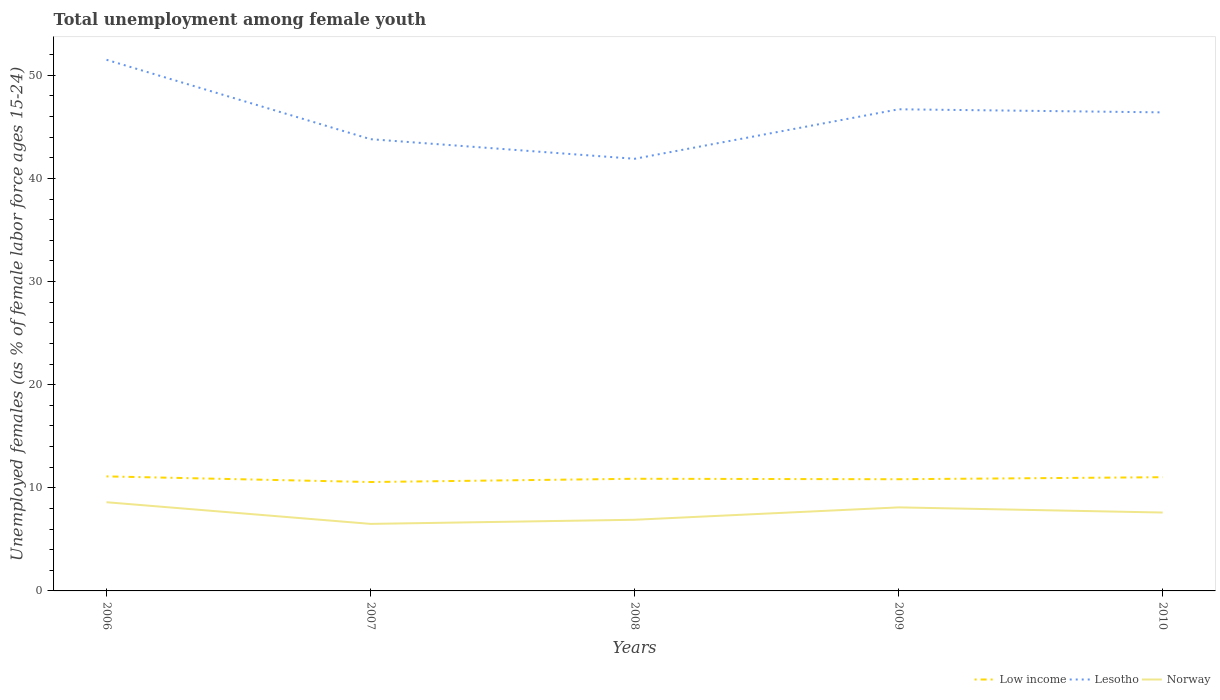How many different coloured lines are there?
Your answer should be very brief. 3. Does the line corresponding to Norway intersect with the line corresponding to Low income?
Your response must be concise. No. Is the number of lines equal to the number of legend labels?
Ensure brevity in your answer.  Yes. Across all years, what is the maximum percentage of unemployed females in in Low income?
Keep it short and to the point. 10.56. In which year was the percentage of unemployed females in in Norway maximum?
Provide a succinct answer. 2007. What is the total percentage of unemployed females in in Low income in the graph?
Keep it short and to the point. -0.47. What is the difference between the highest and the second highest percentage of unemployed females in in Lesotho?
Your answer should be compact. 9.6. Is the percentage of unemployed females in in Norway strictly greater than the percentage of unemployed females in in Lesotho over the years?
Provide a succinct answer. Yes. How many years are there in the graph?
Make the answer very short. 5. Are the values on the major ticks of Y-axis written in scientific E-notation?
Your answer should be very brief. No. How many legend labels are there?
Make the answer very short. 3. What is the title of the graph?
Your answer should be very brief. Total unemployment among female youth. What is the label or title of the X-axis?
Your answer should be compact. Years. What is the label or title of the Y-axis?
Provide a succinct answer. Unemployed females (as % of female labor force ages 15-24). What is the Unemployed females (as % of female labor force ages 15-24) of Low income in 2006?
Offer a terse response. 11.1. What is the Unemployed females (as % of female labor force ages 15-24) in Lesotho in 2006?
Your response must be concise. 51.5. What is the Unemployed females (as % of female labor force ages 15-24) in Norway in 2006?
Provide a succinct answer. 8.6. What is the Unemployed females (as % of female labor force ages 15-24) in Low income in 2007?
Keep it short and to the point. 10.56. What is the Unemployed females (as % of female labor force ages 15-24) in Lesotho in 2007?
Your answer should be very brief. 43.8. What is the Unemployed females (as % of female labor force ages 15-24) in Norway in 2007?
Ensure brevity in your answer.  6.5. What is the Unemployed females (as % of female labor force ages 15-24) of Low income in 2008?
Keep it short and to the point. 10.87. What is the Unemployed females (as % of female labor force ages 15-24) in Lesotho in 2008?
Offer a terse response. 41.9. What is the Unemployed females (as % of female labor force ages 15-24) of Norway in 2008?
Provide a short and direct response. 6.9. What is the Unemployed females (as % of female labor force ages 15-24) in Low income in 2009?
Offer a very short reply. 10.83. What is the Unemployed females (as % of female labor force ages 15-24) in Lesotho in 2009?
Your response must be concise. 46.7. What is the Unemployed females (as % of female labor force ages 15-24) in Norway in 2009?
Your answer should be very brief. 8.1. What is the Unemployed females (as % of female labor force ages 15-24) in Low income in 2010?
Your answer should be very brief. 11.03. What is the Unemployed females (as % of female labor force ages 15-24) in Lesotho in 2010?
Provide a succinct answer. 46.4. What is the Unemployed females (as % of female labor force ages 15-24) of Norway in 2010?
Give a very brief answer. 7.6. Across all years, what is the maximum Unemployed females (as % of female labor force ages 15-24) of Low income?
Make the answer very short. 11.1. Across all years, what is the maximum Unemployed females (as % of female labor force ages 15-24) in Lesotho?
Your response must be concise. 51.5. Across all years, what is the maximum Unemployed females (as % of female labor force ages 15-24) of Norway?
Ensure brevity in your answer.  8.6. Across all years, what is the minimum Unemployed females (as % of female labor force ages 15-24) of Low income?
Your answer should be compact. 10.56. Across all years, what is the minimum Unemployed females (as % of female labor force ages 15-24) of Lesotho?
Provide a succinct answer. 41.9. Across all years, what is the minimum Unemployed females (as % of female labor force ages 15-24) in Norway?
Ensure brevity in your answer.  6.5. What is the total Unemployed females (as % of female labor force ages 15-24) in Low income in the graph?
Offer a terse response. 54.39. What is the total Unemployed females (as % of female labor force ages 15-24) of Lesotho in the graph?
Make the answer very short. 230.3. What is the total Unemployed females (as % of female labor force ages 15-24) of Norway in the graph?
Ensure brevity in your answer.  37.7. What is the difference between the Unemployed females (as % of female labor force ages 15-24) in Low income in 2006 and that in 2007?
Keep it short and to the point. 0.55. What is the difference between the Unemployed females (as % of female labor force ages 15-24) in Low income in 2006 and that in 2008?
Your response must be concise. 0.23. What is the difference between the Unemployed females (as % of female labor force ages 15-24) of Norway in 2006 and that in 2008?
Your answer should be very brief. 1.7. What is the difference between the Unemployed females (as % of female labor force ages 15-24) of Low income in 2006 and that in 2009?
Your answer should be compact. 0.28. What is the difference between the Unemployed females (as % of female labor force ages 15-24) of Norway in 2006 and that in 2009?
Your answer should be compact. 0.5. What is the difference between the Unemployed females (as % of female labor force ages 15-24) in Low income in 2006 and that in 2010?
Provide a succinct answer. 0.08. What is the difference between the Unemployed females (as % of female labor force ages 15-24) of Norway in 2006 and that in 2010?
Your answer should be very brief. 1. What is the difference between the Unemployed females (as % of female labor force ages 15-24) in Low income in 2007 and that in 2008?
Keep it short and to the point. -0.32. What is the difference between the Unemployed females (as % of female labor force ages 15-24) of Lesotho in 2007 and that in 2008?
Give a very brief answer. 1.9. What is the difference between the Unemployed females (as % of female labor force ages 15-24) in Low income in 2007 and that in 2009?
Your answer should be very brief. -0.27. What is the difference between the Unemployed females (as % of female labor force ages 15-24) in Lesotho in 2007 and that in 2009?
Ensure brevity in your answer.  -2.9. What is the difference between the Unemployed females (as % of female labor force ages 15-24) in Low income in 2007 and that in 2010?
Give a very brief answer. -0.47. What is the difference between the Unemployed females (as % of female labor force ages 15-24) of Lesotho in 2007 and that in 2010?
Provide a succinct answer. -2.6. What is the difference between the Unemployed females (as % of female labor force ages 15-24) of Norway in 2007 and that in 2010?
Your response must be concise. -1.1. What is the difference between the Unemployed females (as % of female labor force ages 15-24) of Low income in 2008 and that in 2009?
Provide a short and direct response. 0.04. What is the difference between the Unemployed females (as % of female labor force ages 15-24) of Lesotho in 2008 and that in 2009?
Give a very brief answer. -4.8. What is the difference between the Unemployed females (as % of female labor force ages 15-24) of Low income in 2008 and that in 2010?
Ensure brevity in your answer.  -0.15. What is the difference between the Unemployed females (as % of female labor force ages 15-24) in Lesotho in 2008 and that in 2010?
Provide a short and direct response. -4.5. What is the difference between the Unemployed females (as % of female labor force ages 15-24) in Norway in 2008 and that in 2010?
Give a very brief answer. -0.7. What is the difference between the Unemployed females (as % of female labor force ages 15-24) in Low income in 2009 and that in 2010?
Your response must be concise. -0.2. What is the difference between the Unemployed females (as % of female labor force ages 15-24) in Norway in 2009 and that in 2010?
Provide a short and direct response. 0.5. What is the difference between the Unemployed females (as % of female labor force ages 15-24) in Low income in 2006 and the Unemployed females (as % of female labor force ages 15-24) in Lesotho in 2007?
Ensure brevity in your answer.  -32.7. What is the difference between the Unemployed females (as % of female labor force ages 15-24) in Low income in 2006 and the Unemployed females (as % of female labor force ages 15-24) in Norway in 2007?
Provide a succinct answer. 4.6. What is the difference between the Unemployed females (as % of female labor force ages 15-24) in Low income in 2006 and the Unemployed females (as % of female labor force ages 15-24) in Lesotho in 2008?
Your answer should be compact. -30.8. What is the difference between the Unemployed females (as % of female labor force ages 15-24) in Low income in 2006 and the Unemployed females (as % of female labor force ages 15-24) in Norway in 2008?
Your answer should be very brief. 4.2. What is the difference between the Unemployed females (as % of female labor force ages 15-24) of Lesotho in 2006 and the Unemployed females (as % of female labor force ages 15-24) of Norway in 2008?
Keep it short and to the point. 44.6. What is the difference between the Unemployed females (as % of female labor force ages 15-24) in Low income in 2006 and the Unemployed females (as % of female labor force ages 15-24) in Lesotho in 2009?
Provide a short and direct response. -35.6. What is the difference between the Unemployed females (as % of female labor force ages 15-24) in Low income in 2006 and the Unemployed females (as % of female labor force ages 15-24) in Norway in 2009?
Make the answer very short. 3. What is the difference between the Unemployed females (as % of female labor force ages 15-24) of Lesotho in 2006 and the Unemployed females (as % of female labor force ages 15-24) of Norway in 2009?
Your answer should be compact. 43.4. What is the difference between the Unemployed females (as % of female labor force ages 15-24) of Low income in 2006 and the Unemployed females (as % of female labor force ages 15-24) of Lesotho in 2010?
Offer a terse response. -35.3. What is the difference between the Unemployed females (as % of female labor force ages 15-24) of Low income in 2006 and the Unemployed females (as % of female labor force ages 15-24) of Norway in 2010?
Ensure brevity in your answer.  3.5. What is the difference between the Unemployed females (as % of female labor force ages 15-24) in Lesotho in 2006 and the Unemployed females (as % of female labor force ages 15-24) in Norway in 2010?
Give a very brief answer. 43.9. What is the difference between the Unemployed females (as % of female labor force ages 15-24) in Low income in 2007 and the Unemployed females (as % of female labor force ages 15-24) in Lesotho in 2008?
Offer a terse response. -31.34. What is the difference between the Unemployed females (as % of female labor force ages 15-24) in Low income in 2007 and the Unemployed females (as % of female labor force ages 15-24) in Norway in 2008?
Make the answer very short. 3.66. What is the difference between the Unemployed females (as % of female labor force ages 15-24) of Lesotho in 2007 and the Unemployed females (as % of female labor force ages 15-24) of Norway in 2008?
Ensure brevity in your answer.  36.9. What is the difference between the Unemployed females (as % of female labor force ages 15-24) of Low income in 2007 and the Unemployed females (as % of female labor force ages 15-24) of Lesotho in 2009?
Make the answer very short. -36.14. What is the difference between the Unemployed females (as % of female labor force ages 15-24) in Low income in 2007 and the Unemployed females (as % of female labor force ages 15-24) in Norway in 2009?
Your answer should be very brief. 2.46. What is the difference between the Unemployed females (as % of female labor force ages 15-24) of Lesotho in 2007 and the Unemployed females (as % of female labor force ages 15-24) of Norway in 2009?
Your answer should be very brief. 35.7. What is the difference between the Unemployed females (as % of female labor force ages 15-24) of Low income in 2007 and the Unemployed females (as % of female labor force ages 15-24) of Lesotho in 2010?
Your answer should be compact. -35.84. What is the difference between the Unemployed females (as % of female labor force ages 15-24) of Low income in 2007 and the Unemployed females (as % of female labor force ages 15-24) of Norway in 2010?
Your response must be concise. 2.96. What is the difference between the Unemployed females (as % of female labor force ages 15-24) in Lesotho in 2007 and the Unemployed females (as % of female labor force ages 15-24) in Norway in 2010?
Offer a terse response. 36.2. What is the difference between the Unemployed females (as % of female labor force ages 15-24) of Low income in 2008 and the Unemployed females (as % of female labor force ages 15-24) of Lesotho in 2009?
Provide a short and direct response. -35.83. What is the difference between the Unemployed females (as % of female labor force ages 15-24) in Low income in 2008 and the Unemployed females (as % of female labor force ages 15-24) in Norway in 2009?
Provide a short and direct response. 2.77. What is the difference between the Unemployed females (as % of female labor force ages 15-24) in Lesotho in 2008 and the Unemployed females (as % of female labor force ages 15-24) in Norway in 2009?
Offer a very short reply. 33.8. What is the difference between the Unemployed females (as % of female labor force ages 15-24) in Low income in 2008 and the Unemployed females (as % of female labor force ages 15-24) in Lesotho in 2010?
Offer a very short reply. -35.53. What is the difference between the Unemployed females (as % of female labor force ages 15-24) of Low income in 2008 and the Unemployed females (as % of female labor force ages 15-24) of Norway in 2010?
Give a very brief answer. 3.27. What is the difference between the Unemployed females (as % of female labor force ages 15-24) of Lesotho in 2008 and the Unemployed females (as % of female labor force ages 15-24) of Norway in 2010?
Offer a very short reply. 34.3. What is the difference between the Unemployed females (as % of female labor force ages 15-24) of Low income in 2009 and the Unemployed females (as % of female labor force ages 15-24) of Lesotho in 2010?
Provide a short and direct response. -35.57. What is the difference between the Unemployed females (as % of female labor force ages 15-24) in Low income in 2009 and the Unemployed females (as % of female labor force ages 15-24) in Norway in 2010?
Offer a very short reply. 3.23. What is the difference between the Unemployed females (as % of female labor force ages 15-24) of Lesotho in 2009 and the Unemployed females (as % of female labor force ages 15-24) of Norway in 2010?
Ensure brevity in your answer.  39.1. What is the average Unemployed females (as % of female labor force ages 15-24) in Low income per year?
Your answer should be very brief. 10.88. What is the average Unemployed females (as % of female labor force ages 15-24) in Lesotho per year?
Provide a succinct answer. 46.06. What is the average Unemployed females (as % of female labor force ages 15-24) in Norway per year?
Offer a terse response. 7.54. In the year 2006, what is the difference between the Unemployed females (as % of female labor force ages 15-24) in Low income and Unemployed females (as % of female labor force ages 15-24) in Lesotho?
Make the answer very short. -40.4. In the year 2006, what is the difference between the Unemployed females (as % of female labor force ages 15-24) of Low income and Unemployed females (as % of female labor force ages 15-24) of Norway?
Your answer should be compact. 2.5. In the year 2006, what is the difference between the Unemployed females (as % of female labor force ages 15-24) of Lesotho and Unemployed females (as % of female labor force ages 15-24) of Norway?
Offer a very short reply. 42.9. In the year 2007, what is the difference between the Unemployed females (as % of female labor force ages 15-24) in Low income and Unemployed females (as % of female labor force ages 15-24) in Lesotho?
Your answer should be very brief. -33.24. In the year 2007, what is the difference between the Unemployed females (as % of female labor force ages 15-24) in Low income and Unemployed females (as % of female labor force ages 15-24) in Norway?
Provide a short and direct response. 4.06. In the year 2007, what is the difference between the Unemployed females (as % of female labor force ages 15-24) in Lesotho and Unemployed females (as % of female labor force ages 15-24) in Norway?
Keep it short and to the point. 37.3. In the year 2008, what is the difference between the Unemployed females (as % of female labor force ages 15-24) in Low income and Unemployed females (as % of female labor force ages 15-24) in Lesotho?
Ensure brevity in your answer.  -31.03. In the year 2008, what is the difference between the Unemployed females (as % of female labor force ages 15-24) of Low income and Unemployed females (as % of female labor force ages 15-24) of Norway?
Your answer should be very brief. 3.97. In the year 2009, what is the difference between the Unemployed females (as % of female labor force ages 15-24) in Low income and Unemployed females (as % of female labor force ages 15-24) in Lesotho?
Make the answer very short. -35.87. In the year 2009, what is the difference between the Unemployed females (as % of female labor force ages 15-24) in Low income and Unemployed females (as % of female labor force ages 15-24) in Norway?
Provide a succinct answer. 2.73. In the year 2009, what is the difference between the Unemployed females (as % of female labor force ages 15-24) in Lesotho and Unemployed females (as % of female labor force ages 15-24) in Norway?
Your answer should be compact. 38.6. In the year 2010, what is the difference between the Unemployed females (as % of female labor force ages 15-24) in Low income and Unemployed females (as % of female labor force ages 15-24) in Lesotho?
Offer a very short reply. -35.37. In the year 2010, what is the difference between the Unemployed females (as % of female labor force ages 15-24) of Low income and Unemployed females (as % of female labor force ages 15-24) of Norway?
Keep it short and to the point. 3.43. In the year 2010, what is the difference between the Unemployed females (as % of female labor force ages 15-24) of Lesotho and Unemployed females (as % of female labor force ages 15-24) of Norway?
Offer a very short reply. 38.8. What is the ratio of the Unemployed females (as % of female labor force ages 15-24) of Low income in 2006 to that in 2007?
Your response must be concise. 1.05. What is the ratio of the Unemployed females (as % of female labor force ages 15-24) of Lesotho in 2006 to that in 2007?
Offer a terse response. 1.18. What is the ratio of the Unemployed females (as % of female labor force ages 15-24) of Norway in 2006 to that in 2007?
Offer a very short reply. 1.32. What is the ratio of the Unemployed females (as % of female labor force ages 15-24) in Low income in 2006 to that in 2008?
Your response must be concise. 1.02. What is the ratio of the Unemployed females (as % of female labor force ages 15-24) in Lesotho in 2006 to that in 2008?
Make the answer very short. 1.23. What is the ratio of the Unemployed females (as % of female labor force ages 15-24) in Norway in 2006 to that in 2008?
Provide a succinct answer. 1.25. What is the ratio of the Unemployed females (as % of female labor force ages 15-24) in Low income in 2006 to that in 2009?
Provide a succinct answer. 1.03. What is the ratio of the Unemployed females (as % of female labor force ages 15-24) in Lesotho in 2006 to that in 2009?
Ensure brevity in your answer.  1.1. What is the ratio of the Unemployed females (as % of female labor force ages 15-24) in Norway in 2006 to that in 2009?
Ensure brevity in your answer.  1.06. What is the ratio of the Unemployed females (as % of female labor force ages 15-24) of Lesotho in 2006 to that in 2010?
Offer a terse response. 1.11. What is the ratio of the Unemployed females (as % of female labor force ages 15-24) of Norway in 2006 to that in 2010?
Provide a succinct answer. 1.13. What is the ratio of the Unemployed females (as % of female labor force ages 15-24) of Low income in 2007 to that in 2008?
Ensure brevity in your answer.  0.97. What is the ratio of the Unemployed females (as % of female labor force ages 15-24) in Lesotho in 2007 to that in 2008?
Your response must be concise. 1.05. What is the ratio of the Unemployed females (as % of female labor force ages 15-24) of Norway in 2007 to that in 2008?
Your answer should be very brief. 0.94. What is the ratio of the Unemployed females (as % of female labor force ages 15-24) in Low income in 2007 to that in 2009?
Provide a short and direct response. 0.97. What is the ratio of the Unemployed females (as % of female labor force ages 15-24) in Lesotho in 2007 to that in 2009?
Your response must be concise. 0.94. What is the ratio of the Unemployed females (as % of female labor force ages 15-24) of Norway in 2007 to that in 2009?
Offer a very short reply. 0.8. What is the ratio of the Unemployed females (as % of female labor force ages 15-24) in Low income in 2007 to that in 2010?
Your answer should be very brief. 0.96. What is the ratio of the Unemployed females (as % of female labor force ages 15-24) of Lesotho in 2007 to that in 2010?
Give a very brief answer. 0.94. What is the ratio of the Unemployed females (as % of female labor force ages 15-24) in Norway in 2007 to that in 2010?
Your answer should be very brief. 0.86. What is the ratio of the Unemployed females (as % of female labor force ages 15-24) in Lesotho in 2008 to that in 2009?
Give a very brief answer. 0.9. What is the ratio of the Unemployed females (as % of female labor force ages 15-24) of Norway in 2008 to that in 2009?
Ensure brevity in your answer.  0.85. What is the ratio of the Unemployed females (as % of female labor force ages 15-24) of Low income in 2008 to that in 2010?
Your answer should be compact. 0.99. What is the ratio of the Unemployed females (as % of female labor force ages 15-24) of Lesotho in 2008 to that in 2010?
Your answer should be compact. 0.9. What is the ratio of the Unemployed females (as % of female labor force ages 15-24) of Norway in 2008 to that in 2010?
Provide a succinct answer. 0.91. What is the ratio of the Unemployed females (as % of female labor force ages 15-24) in Low income in 2009 to that in 2010?
Keep it short and to the point. 0.98. What is the ratio of the Unemployed females (as % of female labor force ages 15-24) of Norway in 2009 to that in 2010?
Ensure brevity in your answer.  1.07. What is the difference between the highest and the second highest Unemployed females (as % of female labor force ages 15-24) in Low income?
Your answer should be compact. 0.08. What is the difference between the highest and the second highest Unemployed females (as % of female labor force ages 15-24) of Lesotho?
Provide a short and direct response. 4.8. What is the difference between the highest and the second highest Unemployed females (as % of female labor force ages 15-24) of Norway?
Ensure brevity in your answer.  0.5. What is the difference between the highest and the lowest Unemployed females (as % of female labor force ages 15-24) of Low income?
Provide a short and direct response. 0.55. What is the difference between the highest and the lowest Unemployed females (as % of female labor force ages 15-24) of Norway?
Offer a terse response. 2.1. 